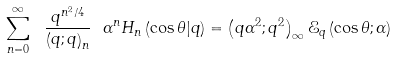Convert formula to latex. <formula><loc_0><loc_0><loc_500><loc_500>\sum _ { n = 0 } ^ { \infty } \ \frac { q ^ { n ^ { 2 } / 4 } } { \left ( q ; q \right ) _ { n } } \ \alpha ^ { n } H _ { n } \left ( \cos \theta | q \right ) = \left ( q \alpha ^ { 2 } ; q ^ { 2 } \right ) _ { \infty } \mathcal { E } _ { q } \left ( \cos \theta ; \alpha \right )</formula> 